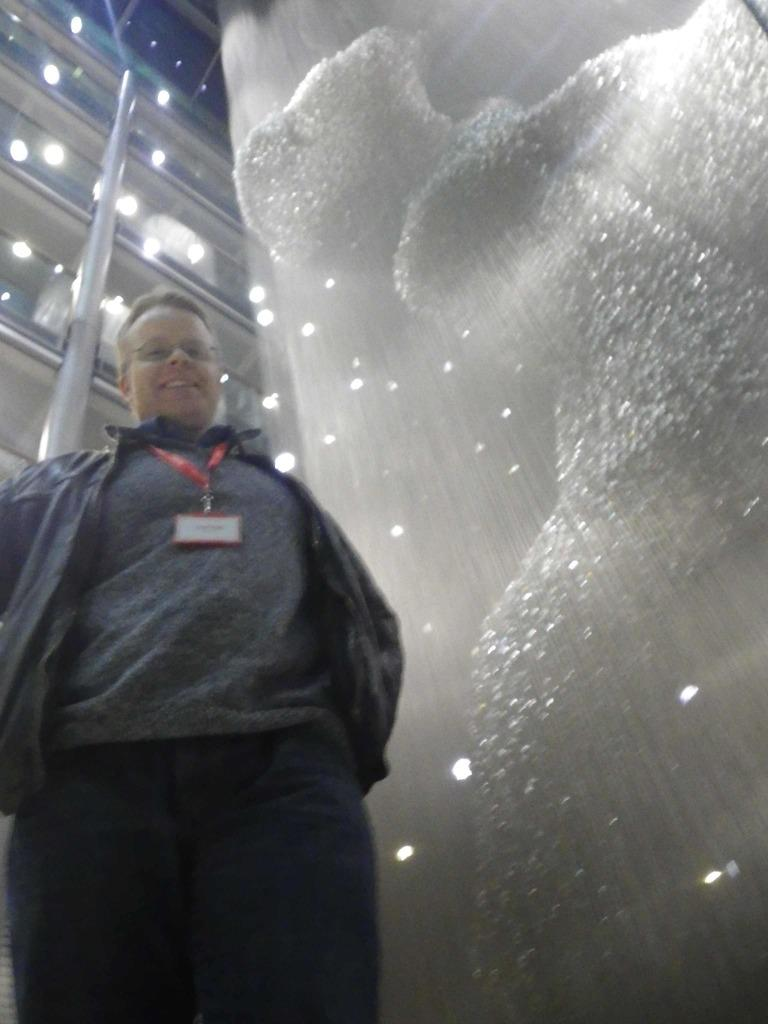What can be seen on the left side of the image? There is a person standing on the left side of the image. What is the person wearing? The person is wearing a black jacket. What item does the person have that might be used for identification? The person has an identity card. What is the color of the object on the right side of the image? The object on the right side of the image is white. What can be seen at the top of the image? There are lights visible at the top of the image, and there are railings as well. What type of soup is being served in the image? There is no soup present in the image. What instrument is the person playing in the image? There is no drum or any musical instrument visible in the image. 